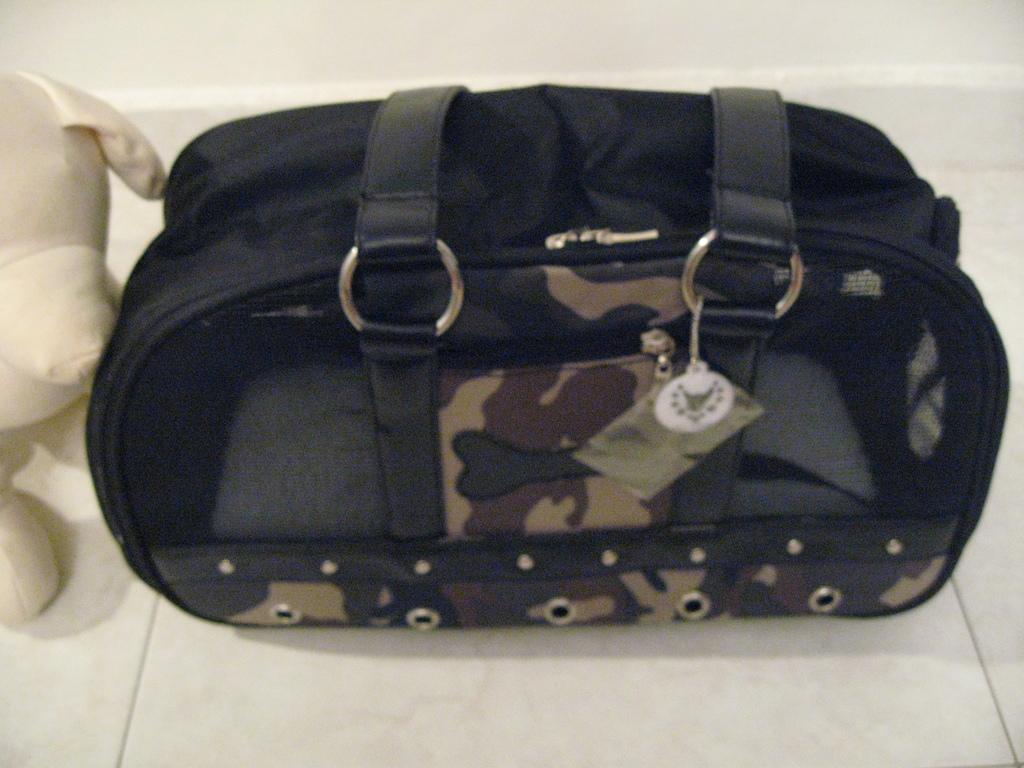What object is on the floor in the image? There is a bag on the floor in the image. What type of tax is being discussed in the image? There is no discussion of tax in the image; it only features a bag on the floor. 